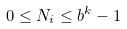Convert formula to latex. <formula><loc_0><loc_0><loc_500><loc_500>0 \leq N _ { i } \leq b ^ { k } - 1</formula> 